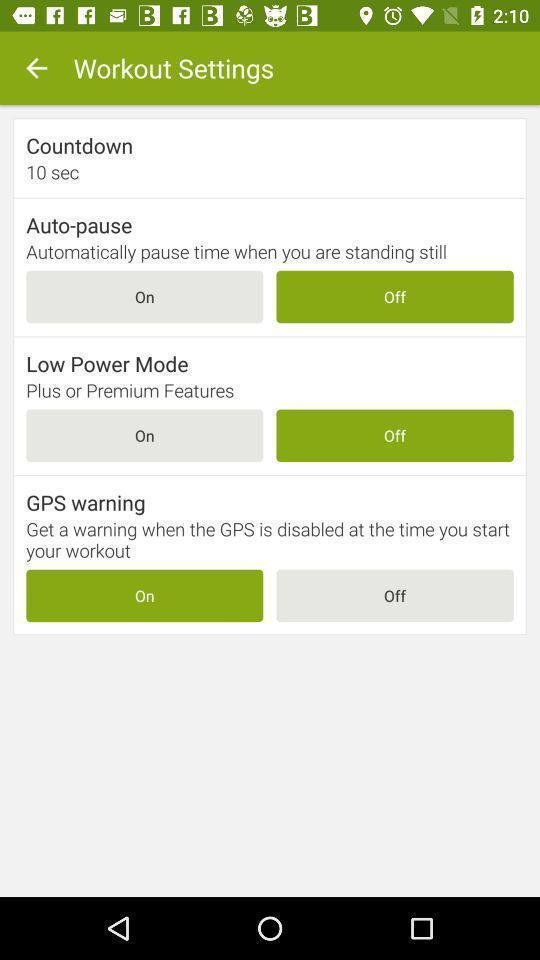Tell me what you see in this picture. Settings of fitness app are displaying. 